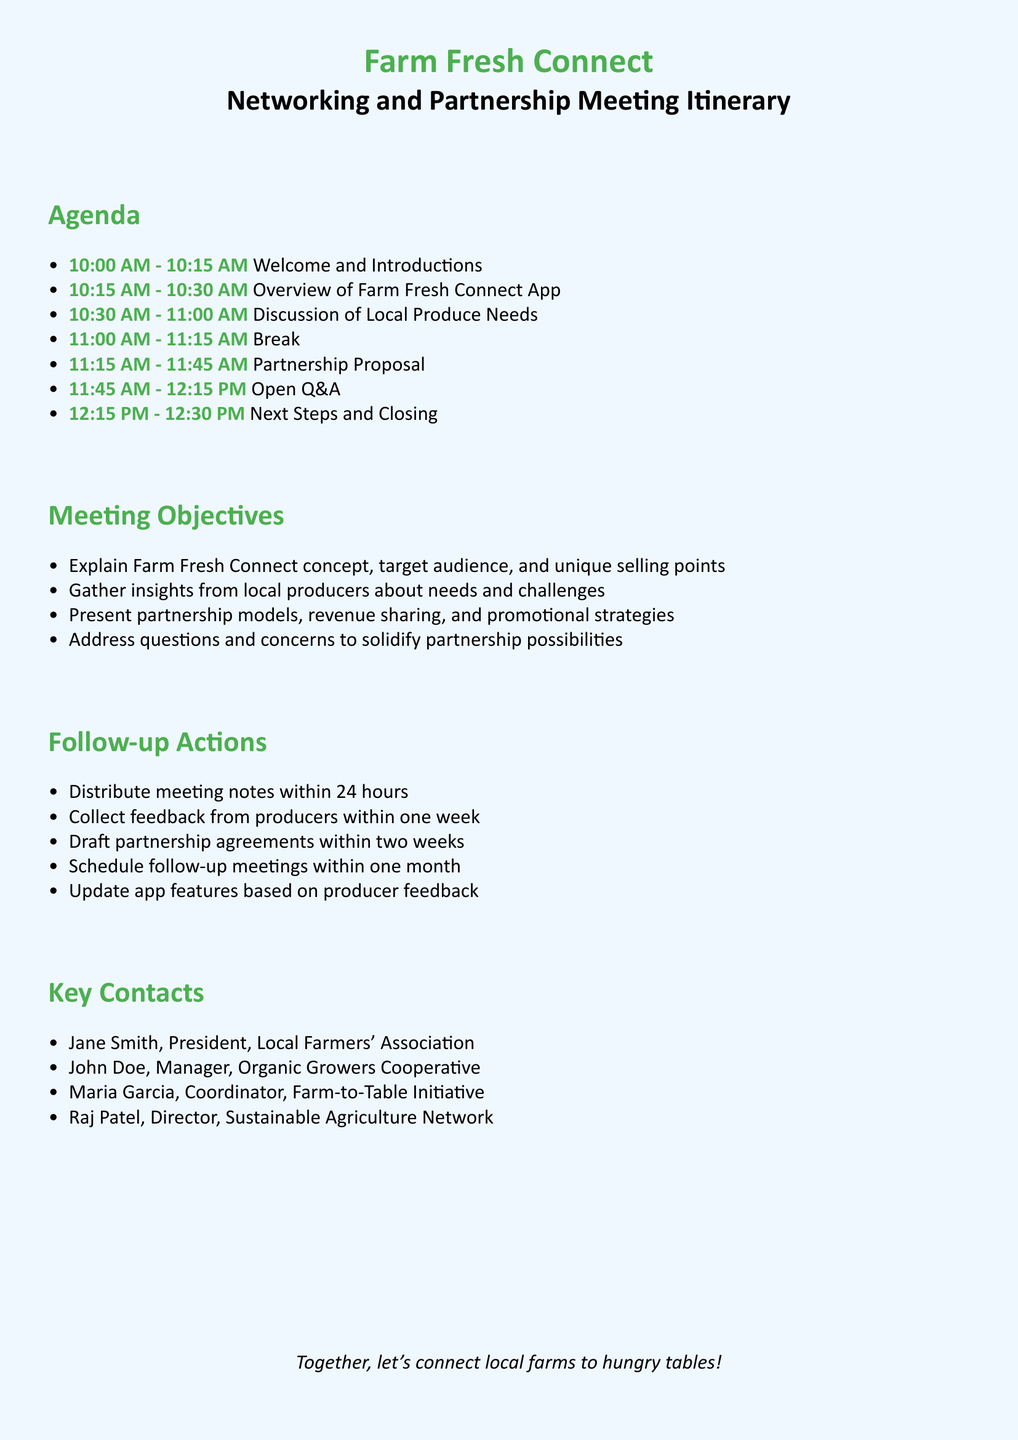What time does the meeting start? The meeting starts at the time listed in the Agenda section, which specifies the beginning of the Welcome and Introductions.
Answer: 10:00 AM Who is the President of the Local Farmers' Association? The document provides the name of the President under the Key Contacts section.
Answer: Jane Smith How long is the Partnership Proposal segment? The duration of each segment is detailed in the Agenda, which includes the time allocations for each part of the meeting.
Answer: 30 minutes What are the follow-up actions to be completed within one week? The Follow-up Actions section outlines the response time for collecting feedback from producers.
Answer: Collect feedback What is the purpose of the Open Q&A session? The objectives of each agenda item help explain the purpose of the Q&A session. It aims to address questions and concerns related to partnerships.
Answer: Solidify partnership possibilities What is one objective related to local producers? The Meeting Objectives section discusses various objectives focused on local producers and their insights.
Answer: Gather insights When will the meeting notes be distributed? Specific timelines for follow-up actions are stated in the Follow-up Actions section.
Answer: Within 24 hours Who is the Coordinator of the Farm-to-Table Initiative? The names and titles of key contacts are provided in the Key Contacts section.
Answer: Maria Garcia 